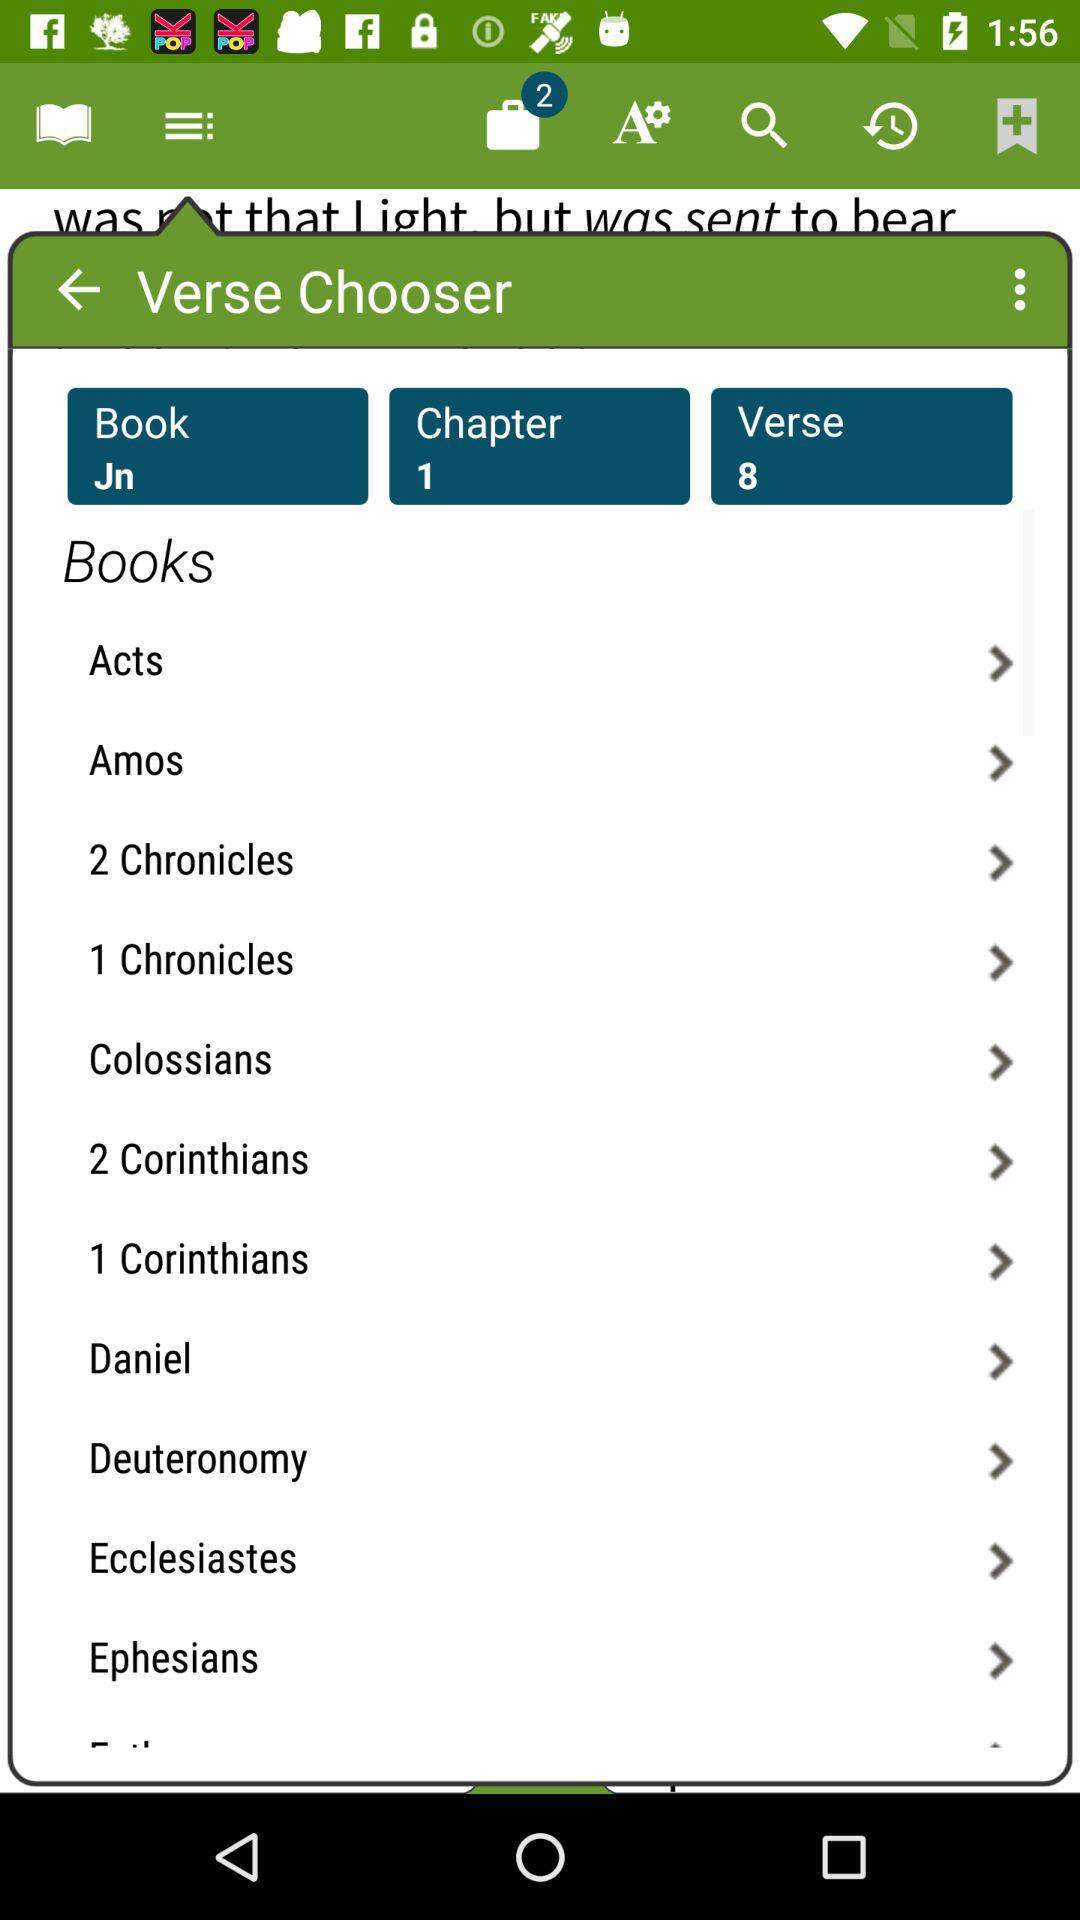What is the chapter number? The chapter number is 1. 